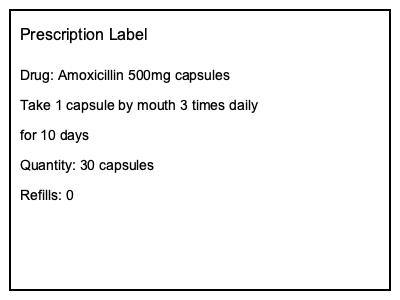Based on the prescription label shown, how many total capsules should the patient take over the entire course of treatment? To determine the total number of capsules the patient should take over the entire course of treatment, we need to follow these steps:

1. Identify the dosage frequency:
   The label states "Take 1 capsule by mouth 3 times daily"
   This means 3 capsules per day

2. Identify the duration of treatment:
   The label states "for 10 days"

3. Calculate the total number of capsules:
   Number of capsules per day × Number of days
   $3 \text{ capsules/day} \times 10 \text{ days} = 30 \text{ capsules}$

4. Verify the quantity prescribed:
   The label shows "Quantity: 30 capsules"
   This matches our calculation, confirming the correct total

Therefore, the patient should take a total of 30 capsules over the entire course of treatment.
Answer: 30 capsules 